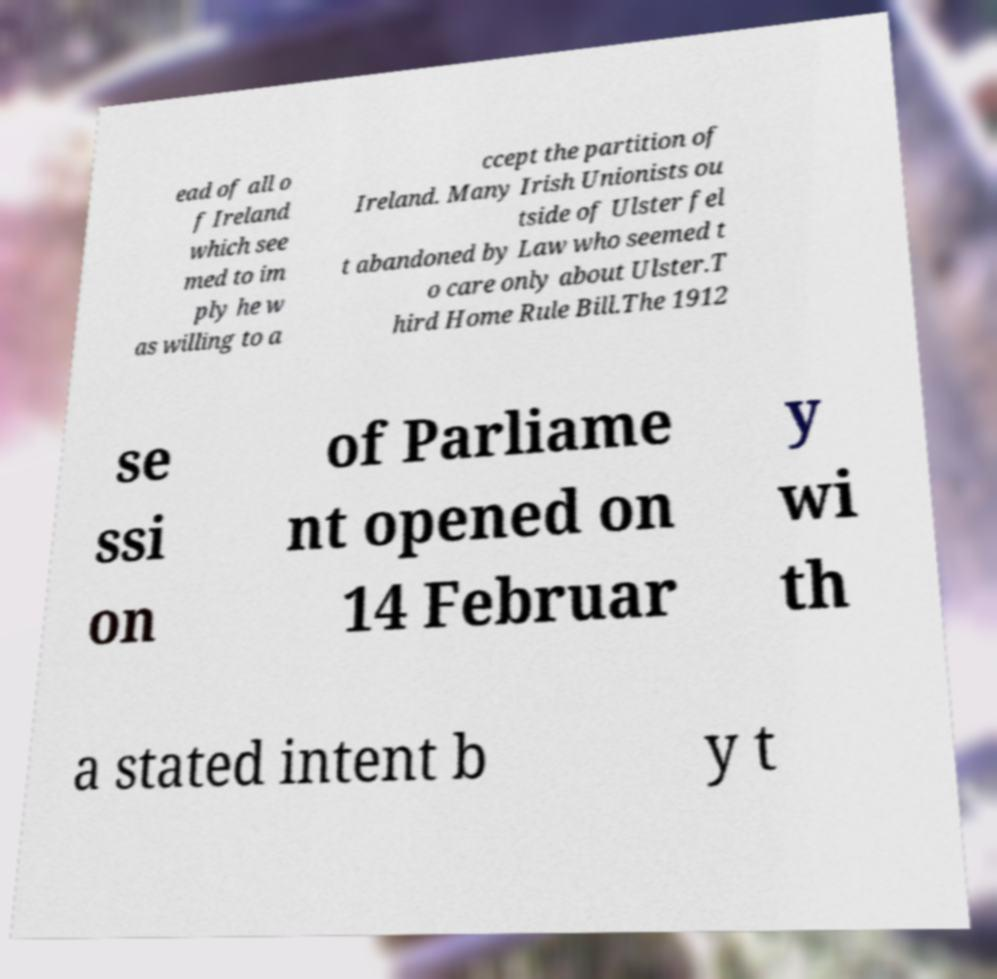Please identify and transcribe the text found in this image. ead of all o f Ireland which see med to im ply he w as willing to a ccept the partition of Ireland. Many Irish Unionists ou tside of Ulster fel t abandoned by Law who seemed t o care only about Ulster.T hird Home Rule Bill.The 1912 se ssi on of Parliame nt opened on 14 Februar y wi th a stated intent b y t 